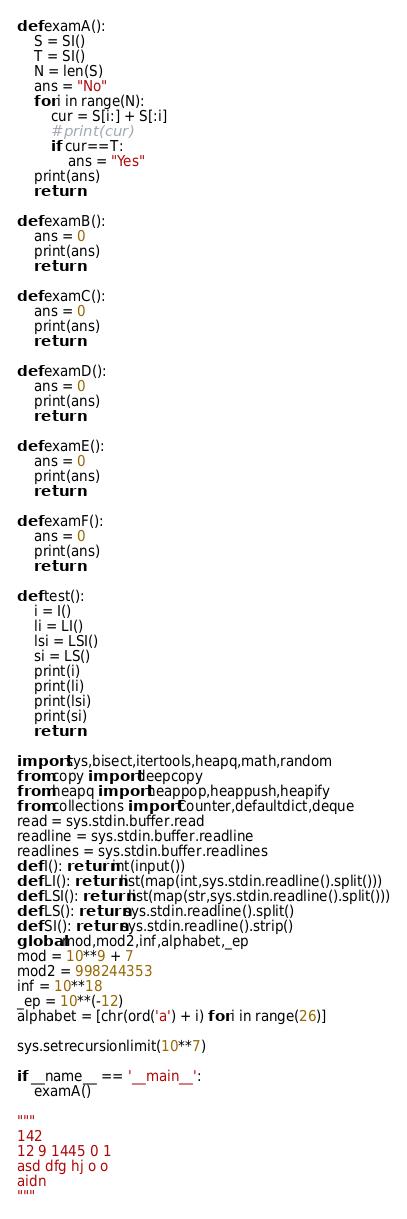Convert code to text. <code><loc_0><loc_0><loc_500><loc_500><_Python_>def examA():
    S = SI()
    T = SI()
    N = len(S)
    ans = "No"
    for i in range(N):
        cur = S[i:] + S[:i]
        #print(cur)
        if cur==T:
            ans = "Yes"
    print(ans)
    return

def examB():
    ans = 0
    print(ans)
    return

def examC():
    ans = 0
    print(ans)
    return

def examD():
    ans = 0
    print(ans)
    return

def examE():
    ans = 0
    print(ans)
    return

def examF():
    ans = 0
    print(ans)
    return

def test():
    i = I()
    li = LI()
    lsi = LSI()
    si = LS()
    print(i)
    print(li)
    print(lsi)
    print(si)
    return

import sys,bisect,itertools,heapq,math,random
from copy import deepcopy
from heapq import heappop,heappush,heapify
from collections import Counter,defaultdict,deque
read = sys.stdin.buffer.read
readline = sys.stdin.buffer.readline
readlines = sys.stdin.buffer.readlines
def I(): return int(input())
def LI(): return list(map(int,sys.stdin.readline().split()))
def LSI(): return list(map(str,sys.stdin.readline().split()))
def LS(): return sys.stdin.readline().split()
def SI(): return sys.stdin.readline().strip()
global mod,mod2,inf,alphabet,_ep
mod = 10**9 + 7
mod2 = 998244353
inf = 10**18
_ep = 10**(-12)
alphabet = [chr(ord('a') + i) for i in range(26)]

sys.setrecursionlimit(10**7)

if __name__ == '__main__':
    examA()

"""
142
12 9 1445 0 1
asd dfg hj o o
aidn
"""</code> 